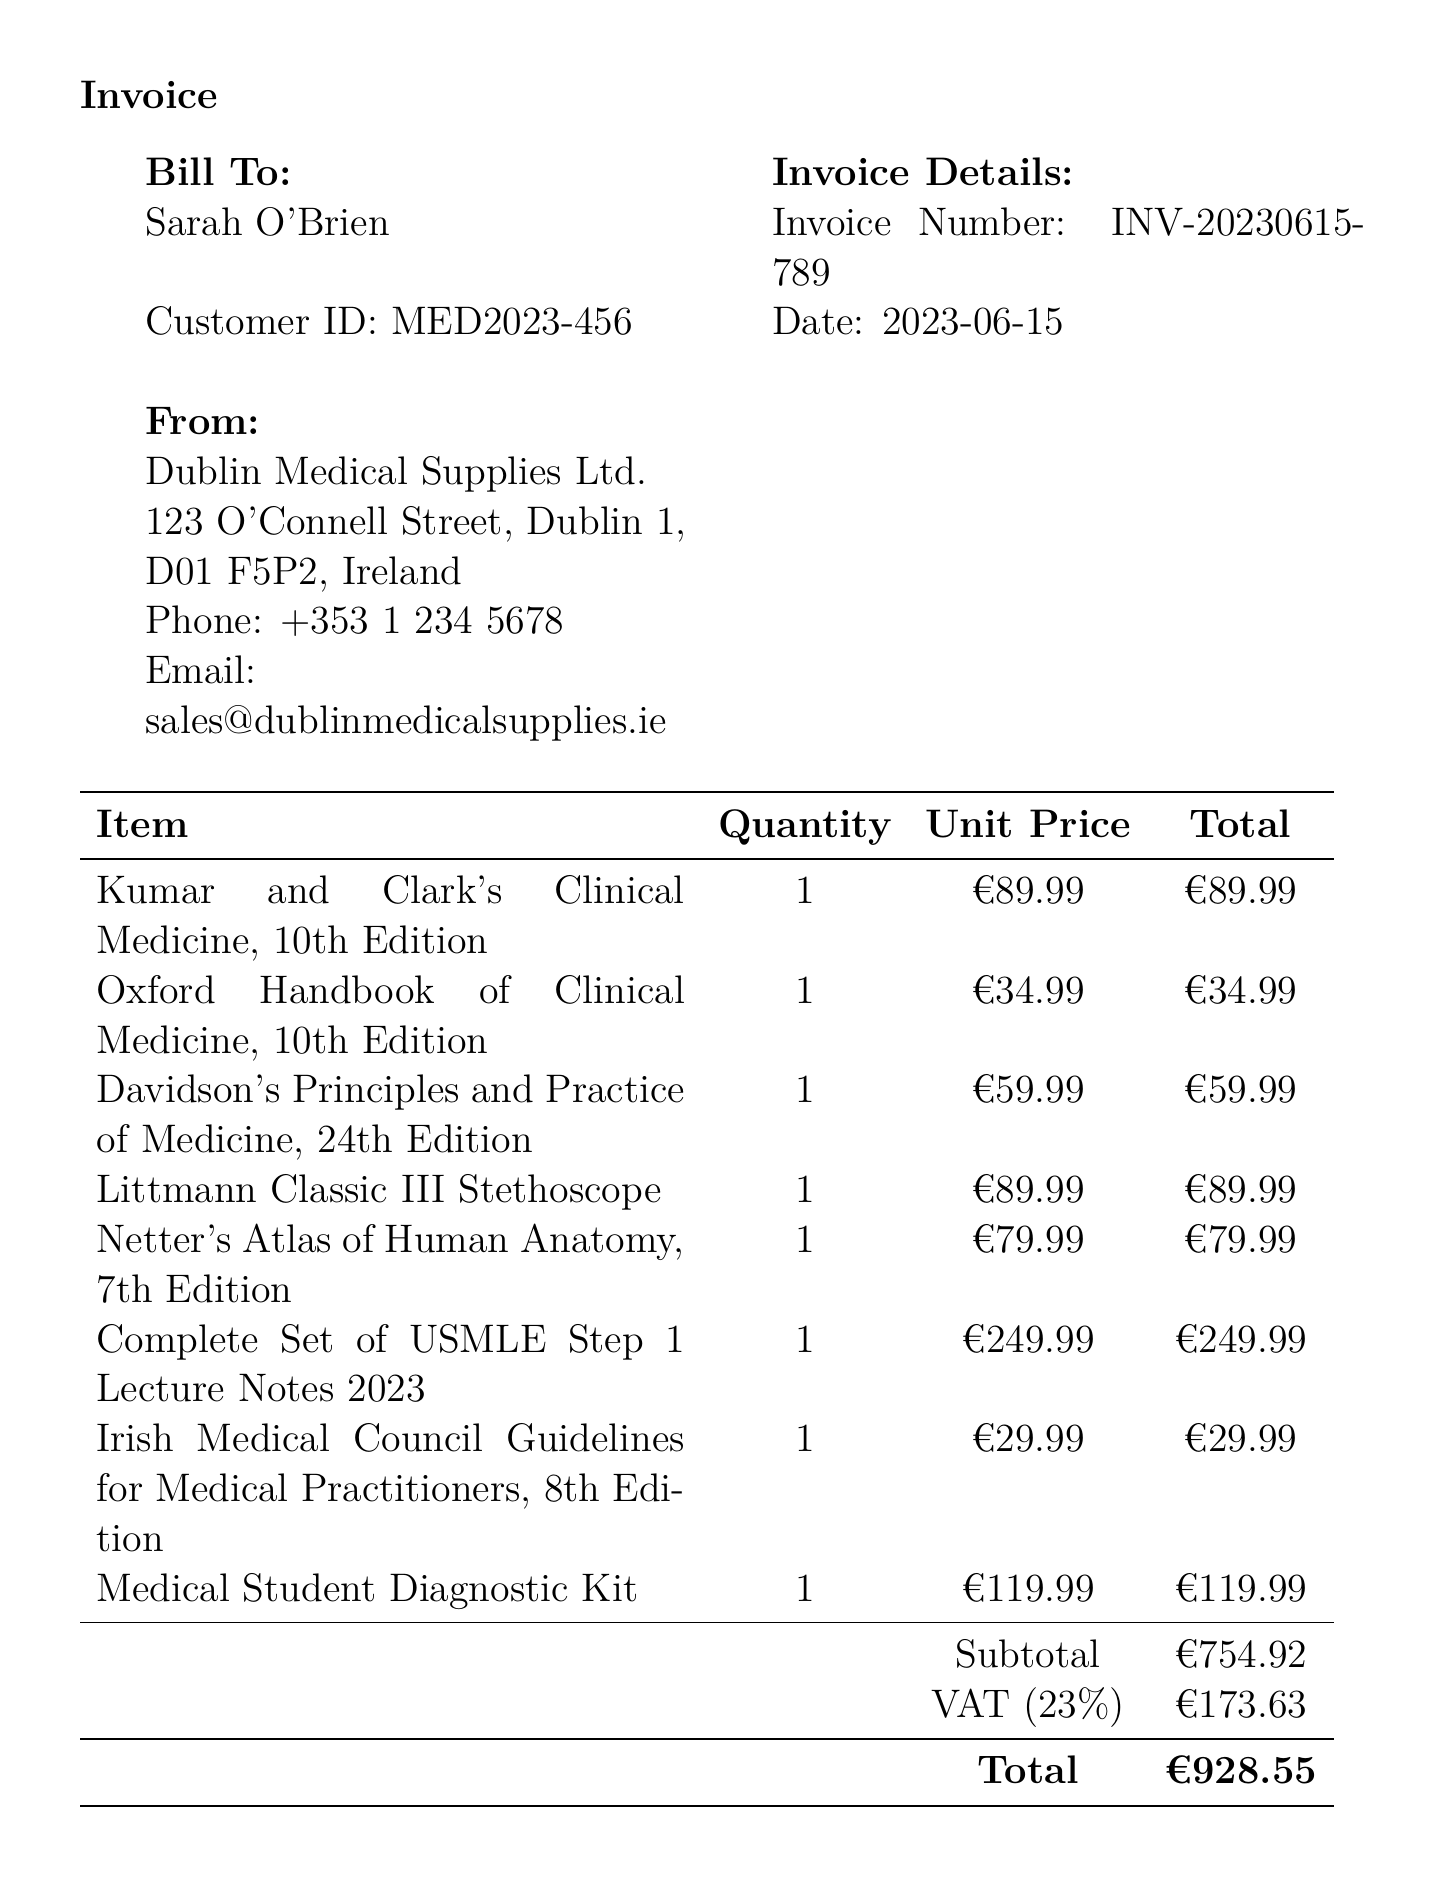What is the store name? The store name is stated at the top of the invoice document.
Answer: Dublin Medical Supplies Ltd Who is the customer? The customer’s name is mentioned in the 'Bill To' section of the invoice.
Answer: Sarah O'Brien What is the invoice number? The invoice number is listed alongside the Invoice Details.
Answer: INV-20230615-789 What is the date of purchase? The purchase date appears in the Invoice Details section.
Answer: 2023-06-15 What is the total amount? The total amount is calculated and presented at the bottom of the invoice.
Answer: €928.55 What item has the highest unit price? The item with the highest unit price is determined from the list of purchased items.
Answer: Complete Set of USMLE Step 1 Lecture Notes 2023 What is the VAT rate? The VAT rate is provided in the section detailing taxes.
Answer: 23% Which payment method was used? The payment method is stated towards the bottom of the invoice.
Answer: Credit Card What does the note section say? The note section expresses gratitude and offers best wishes to the customer.
Answer: Thank you for your purchase. These materials are essential for your internal medicine specialization. Good luck with your studies at the Royal College of Surgeons in Ireland! 